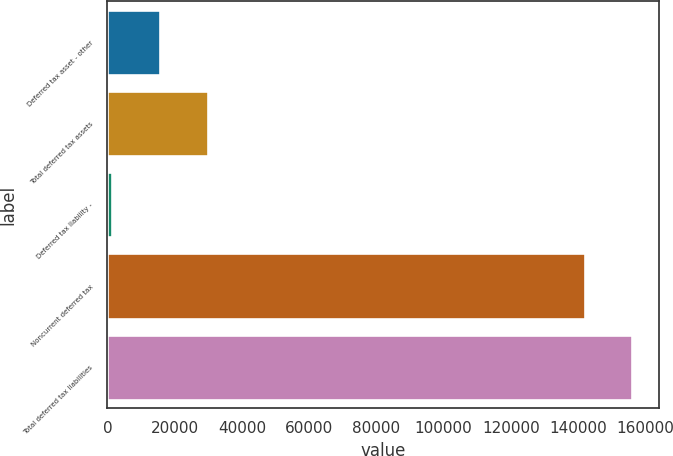Convert chart. <chart><loc_0><loc_0><loc_500><loc_500><bar_chart><fcel>Deferred tax asset - other<fcel>Total deferred tax assets<fcel>Deferred tax liability -<fcel>Noncurrent deferred tax<fcel>Total deferred tax liabilities<nl><fcel>15669.4<fcel>29867.8<fcel>1471<fcel>141984<fcel>156182<nl></chart> 